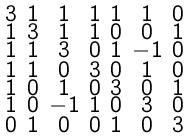<formula> <loc_0><loc_0><loc_500><loc_500>\begin{smallmatrix} 3 & 1 & 1 & 1 & 1 & 1 & 0 \\ 1 & 3 & 1 & 1 & 0 & 0 & 1 \\ 1 & 1 & 3 & 0 & 1 & - 1 & 0 \\ 1 & 1 & 0 & 3 & 0 & 1 & 0 \\ 1 & 0 & 1 & 0 & 3 & 0 & 1 \\ 1 & 0 & - 1 & 1 & 0 & 3 & 0 \\ 0 & 1 & 0 & 0 & 1 & 0 & 3 \end{smallmatrix}</formula> 